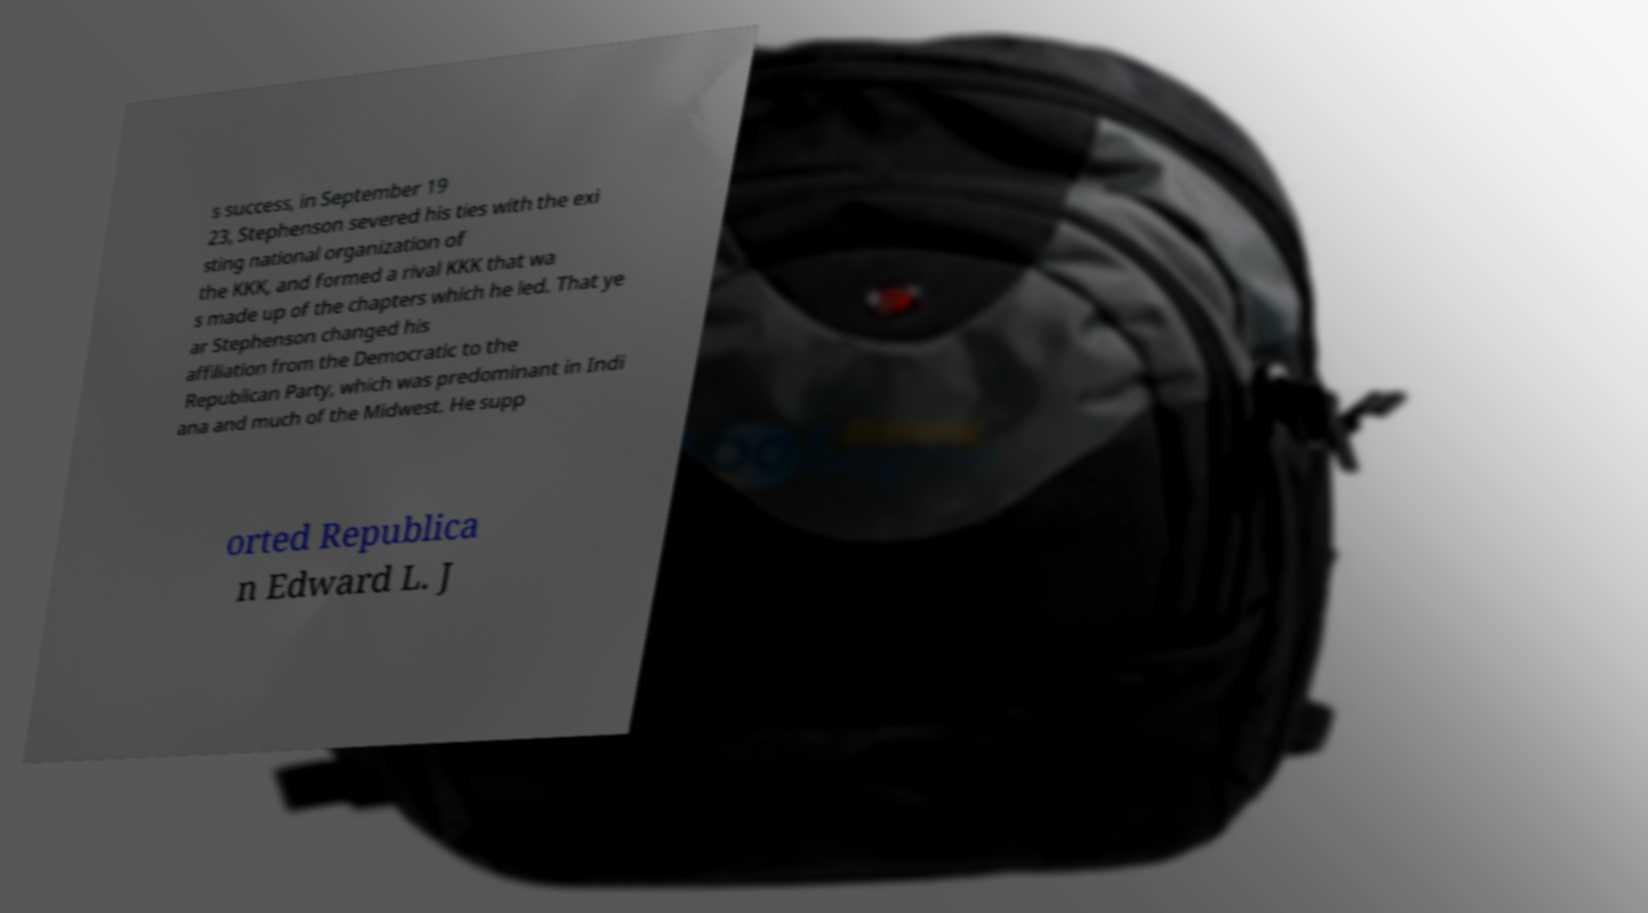Could you assist in decoding the text presented in this image and type it out clearly? s success, in September 19 23, Stephenson severed his ties with the exi sting national organization of the KKK, and formed a rival KKK that wa s made up of the chapters which he led. That ye ar Stephenson changed his affiliation from the Democratic to the Republican Party, which was predominant in Indi ana and much of the Midwest. He supp orted Republica n Edward L. J 